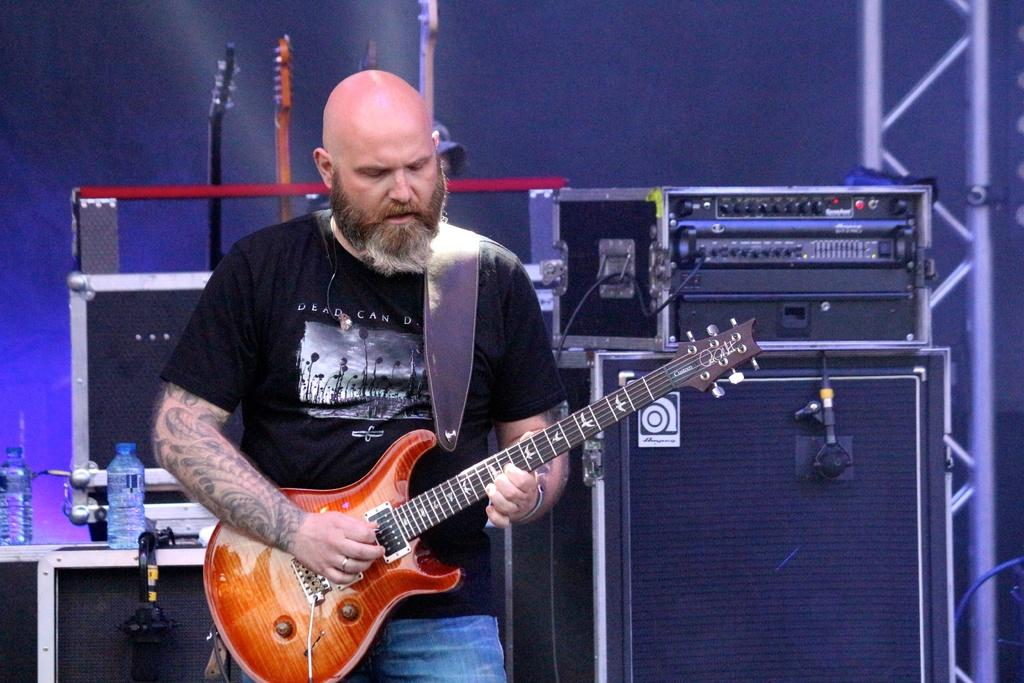What is the man in the image doing? The man is playing the guitar. What instrument is the man holding in the image? The man is holding a guitar. What can be seen in the background of the image? In the background of the image, there are speakers, a device, bottles, rods, and a pillar. What type of appliance is the man using to play the guitar in the image? There is no appliance present in the image; the man is playing the guitar without any additional equipment. 